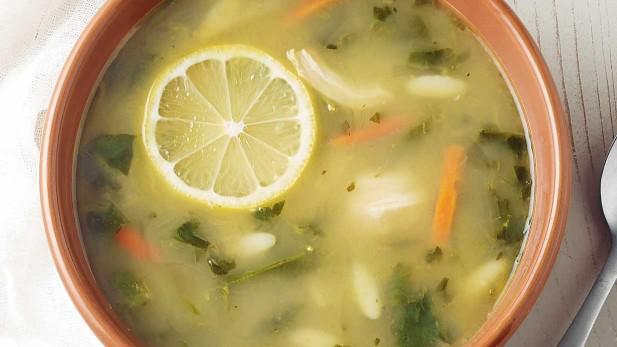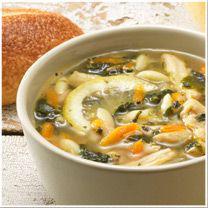The first image is the image on the left, the second image is the image on the right. Given the left and right images, does the statement "There are two lemon slices to the right of a white bowl with soap." hold true? Answer yes or no. No. 